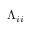Convert formula to latex. <formula><loc_0><loc_0><loc_500><loc_500>\Lambda _ { i i }</formula> 